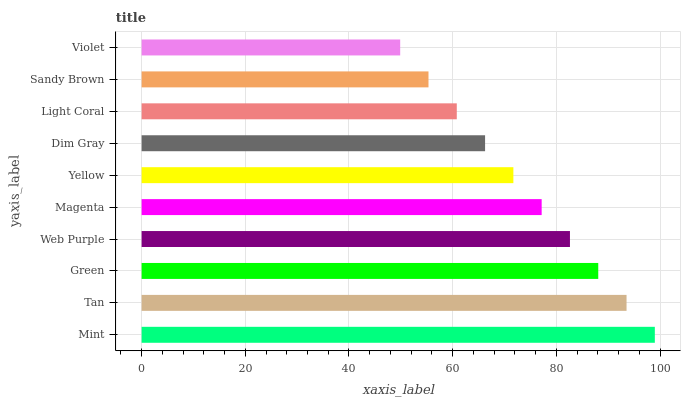Is Violet the minimum?
Answer yes or no. Yes. Is Mint the maximum?
Answer yes or no. Yes. Is Tan the minimum?
Answer yes or no. No. Is Tan the maximum?
Answer yes or no. No. Is Mint greater than Tan?
Answer yes or no. Yes. Is Tan less than Mint?
Answer yes or no. Yes. Is Tan greater than Mint?
Answer yes or no. No. Is Mint less than Tan?
Answer yes or no. No. Is Magenta the high median?
Answer yes or no. Yes. Is Yellow the low median?
Answer yes or no. Yes. Is Dim Gray the high median?
Answer yes or no. No. Is Web Purple the low median?
Answer yes or no. No. 